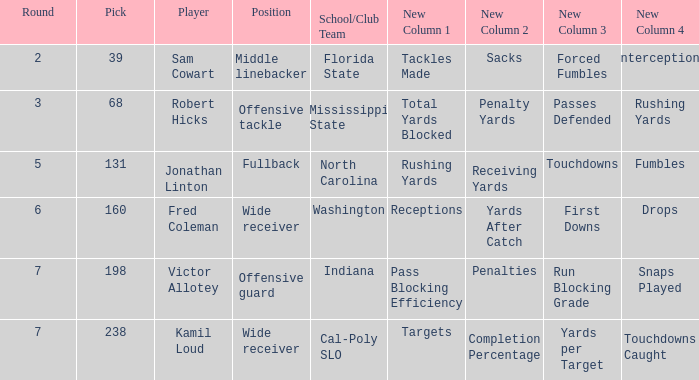Which Round has a School/Club Team of indiana, and a Pick smaller than 198? None. 